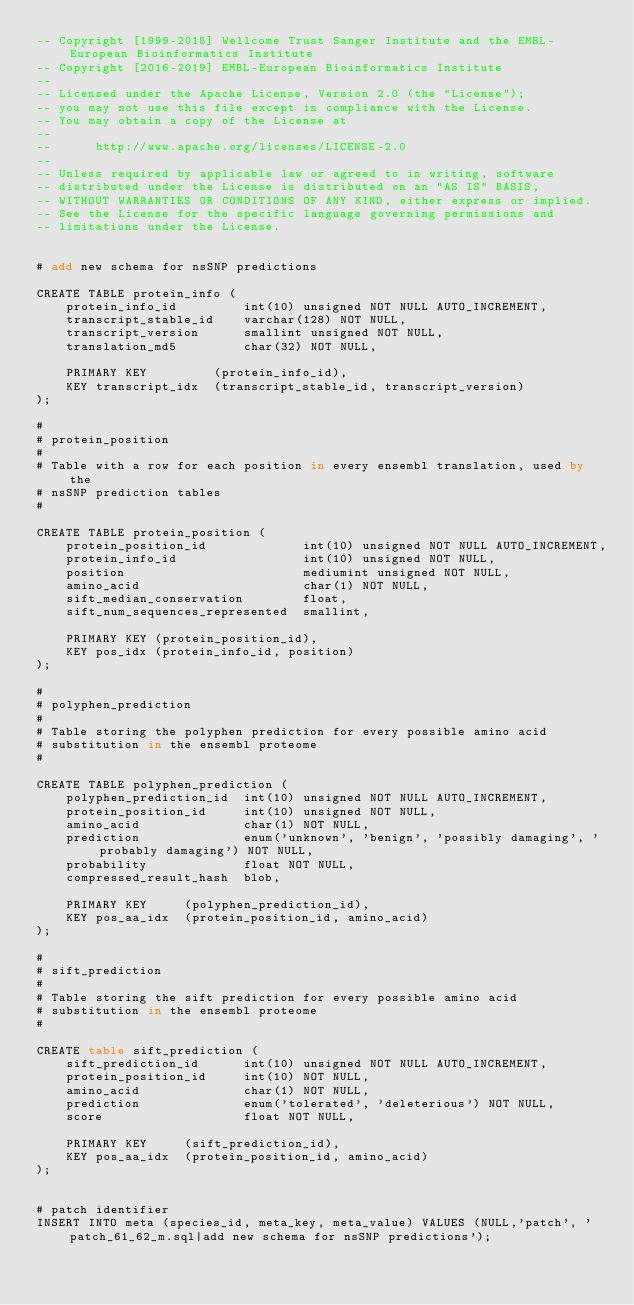Convert code to text. <code><loc_0><loc_0><loc_500><loc_500><_SQL_>-- Copyright [1999-2015] Wellcome Trust Sanger Institute and the EMBL-European Bioinformatics Institute
-- Copyright [2016-2019] EMBL-European Bioinformatics Institute
-- 
-- Licensed under the Apache License, Version 2.0 (the "License");
-- you may not use this file except in compliance with the License.
-- You may obtain a copy of the License at
-- 
--      http://www.apache.org/licenses/LICENSE-2.0
-- 
-- Unless required by applicable law or agreed to in writing, software
-- distributed under the License is distributed on an "AS IS" BASIS,
-- WITHOUT WARRANTIES OR CONDITIONS OF ANY KIND, either express or implied.
-- See the License for the specific language governing permissions and
-- limitations under the License.


# add new schema for nsSNP predictions 

CREATE TABLE protein_info (
    protein_info_id         int(10) unsigned NOT NULL AUTO_INCREMENT,
    transcript_stable_id    varchar(128) NOT NULL,
    transcript_version      smallint unsigned NOT NULL,
    translation_md5         char(32) NOT NULL,

    PRIMARY KEY         (protein_info_id),
    KEY transcript_idx  (transcript_stable_id, transcript_version)
);

#
# protein_position
#
# Table with a row for each position in every ensembl translation, used by the
# nsSNP prediction tables
#

CREATE TABLE protein_position (
    protein_position_id             int(10) unsigned NOT NULL AUTO_INCREMENT,
    protein_info_id                 int(10) unsigned NOT NULL,
    position                        mediumint unsigned NOT NULL,
    amino_acid                      char(1) NOT NULL,
    sift_median_conservation        float,
    sift_num_sequences_represented  smallint,

    PRIMARY KEY (protein_position_id),
    KEY pos_idx (protein_info_id, position)
);

#
# polyphen_prediction
#
# Table storing the polyphen prediction for every possible amino acid
# substitution in the ensembl proteome
#

CREATE TABLE polyphen_prediction (
    polyphen_prediction_id  int(10) unsigned NOT NULL AUTO_INCREMENT,
    protein_position_id     int(10) unsigned NOT NULL,
    amino_acid              char(1) NOT NULL,
    prediction              enum('unknown', 'benign', 'possibly damaging', 'probably damaging') NOT NULL,
    probability             float NOT NULL,
    compressed_result_hash  blob,
    
    PRIMARY KEY     (polyphen_prediction_id),
    KEY pos_aa_idx  (protein_position_id, amino_acid)
);

#
# sift_prediction
#
# Table storing the sift prediction for every possible amino acid
# substitution in the ensembl proteome
#

CREATE table sift_prediction (
    sift_prediction_id      int(10) unsigned NOT NULL AUTO_INCREMENT,
    protein_position_id     int(10) NOT NULL,
    amino_acid              char(1) NOT NULL,
    prediction              enum('tolerated', 'deleterious') NOT NULL,
    score                   float NOT NULL,

    PRIMARY KEY     (sift_prediction_id),
    KEY pos_aa_idx  (protein_position_id, amino_acid)
);


# patch identifier
INSERT INTO meta (species_id, meta_key, meta_value) VALUES (NULL,'patch', 'patch_61_62_m.sql|add new schema for nsSNP predictions');

</code> 